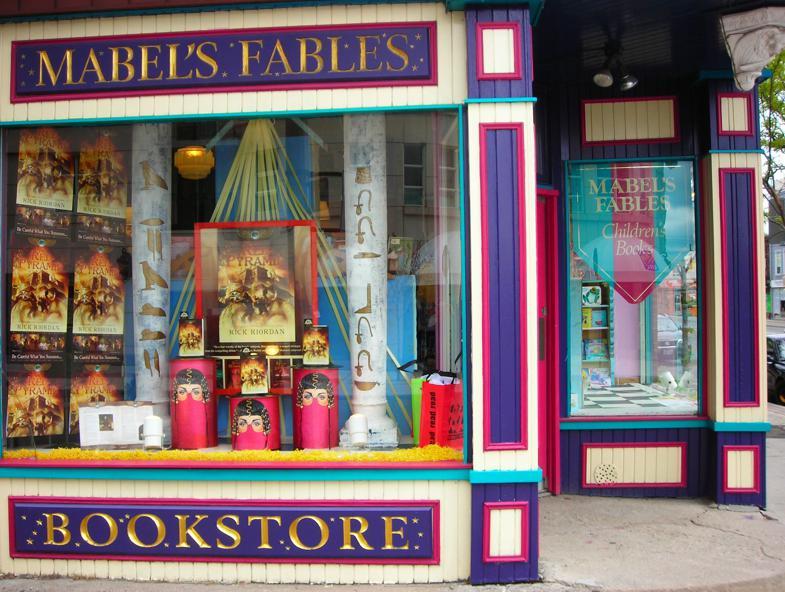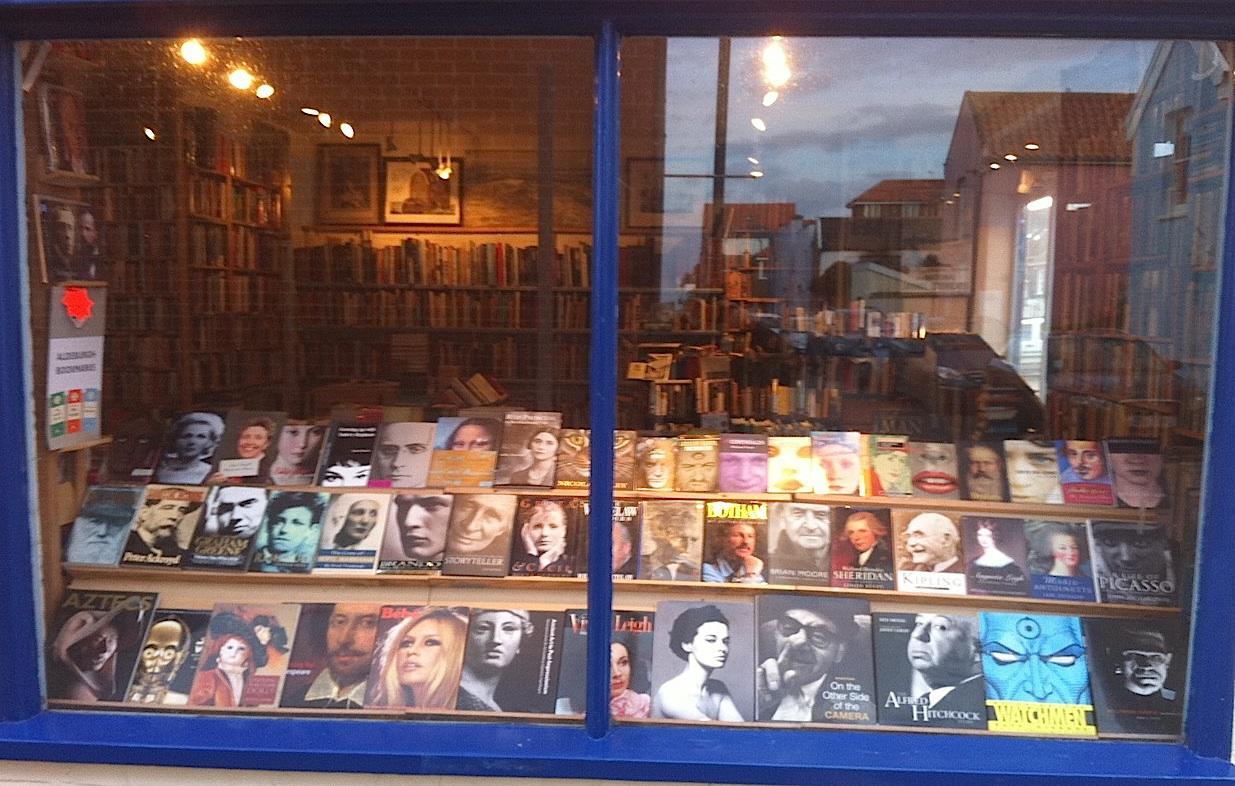The first image is the image on the left, the second image is the image on the right. Given the left and right images, does the statement "One of the images features a light blue storefront that has a moon on display." hold true? Answer yes or no. No. The first image is the image on the left, the second image is the image on the right. Given the left and right images, does the statement "in both images, the storefronts show the store name on them" hold true? Answer yes or no. No. 